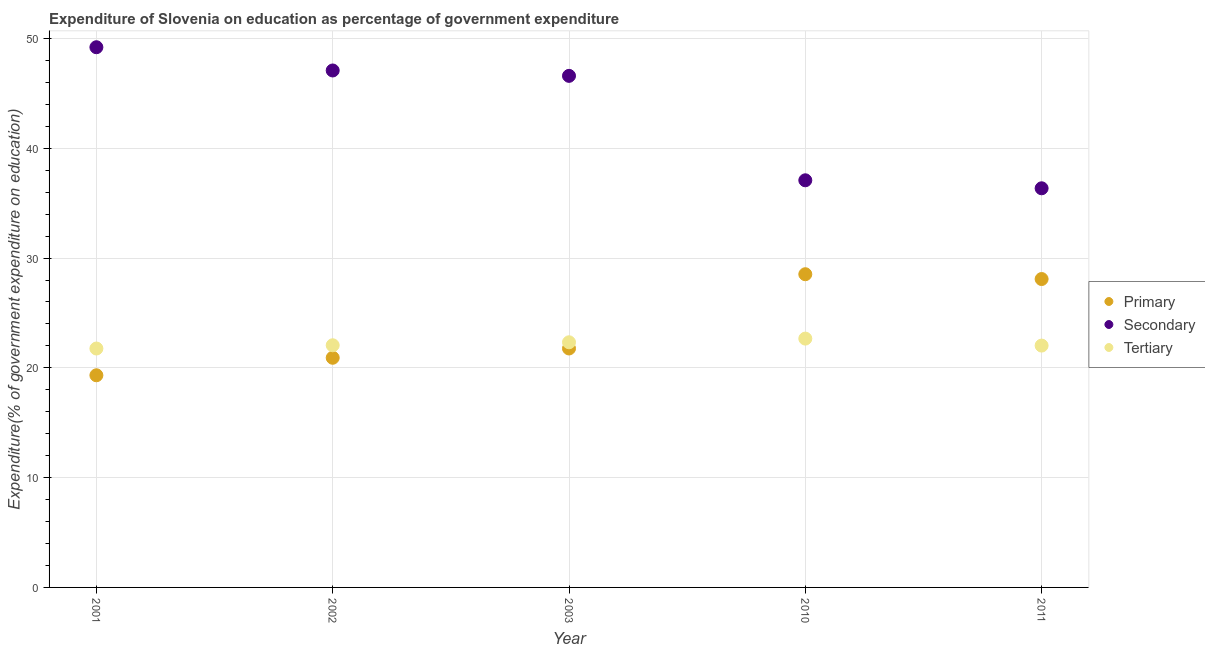How many different coloured dotlines are there?
Give a very brief answer. 3. What is the expenditure on tertiary education in 2003?
Make the answer very short. 22.33. Across all years, what is the maximum expenditure on secondary education?
Provide a short and direct response. 49.2. Across all years, what is the minimum expenditure on secondary education?
Offer a terse response. 36.35. In which year was the expenditure on secondary education minimum?
Offer a very short reply. 2011. What is the total expenditure on primary education in the graph?
Your response must be concise. 118.62. What is the difference between the expenditure on tertiary education in 2002 and that in 2011?
Offer a very short reply. 0.03. What is the difference between the expenditure on primary education in 2003 and the expenditure on tertiary education in 2001?
Make the answer very short. 0. What is the average expenditure on primary education per year?
Your response must be concise. 23.72. In the year 2011, what is the difference between the expenditure on tertiary education and expenditure on secondary education?
Offer a terse response. -14.33. In how many years, is the expenditure on secondary education greater than 22 %?
Offer a very short reply. 5. What is the ratio of the expenditure on secondary education in 2001 to that in 2002?
Give a very brief answer. 1.04. Is the expenditure on tertiary education in 2002 less than that in 2011?
Offer a terse response. No. What is the difference between the highest and the second highest expenditure on secondary education?
Give a very brief answer. 2.12. What is the difference between the highest and the lowest expenditure on tertiary education?
Your response must be concise. 0.9. Is the sum of the expenditure on primary education in 2001 and 2011 greater than the maximum expenditure on secondary education across all years?
Your answer should be very brief. No. Is it the case that in every year, the sum of the expenditure on primary education and expenditure on secondary education is greater than the expenditure on tertiary education?
Make the answer very short. Yes. Does the expenditure on tertiary education monotonically increase over the years?
Offer a terse response. No. How many dotlines are there?
Keep it short and to the point. 3. Are the values on the major ticks of Y-axis written in scientific E-notation?
Your answer should be very brief. No. Where does the legend appear in the graph?
Offer a very short reply. Center right. How many legend labels are there?
Offer a very short reply. 3. How are the legend labels stacked?
Offer a very short reply. Vertical. What is the title of the graph?
Keep it short and to the point. Expenditure of Slovenia on education as percentage of government expenditure. Does "Infant(male)" appear as one of the legend labels in the graph?
Offer a terse response. No. What is the label or title of the Y-axis?
Provide a short and direct response. Expenditure(% of government expenditure on education). What is the Expenditure(% of government expenditure on education) of Primary in 2001?
Offer a terse response. 19.32. What is the Expenditure(% of government expenditure on education) of Secondary in 2001?
Give a very brief answer. 49.2. What is the Expenditure(% of government expenditure on education) in Tertiary in 2001?
Keep it short and to the point. 21.76. What is the Expenditure(% of government expenditure on education) of Primary in 2002?
Ensure brevity in your answer.  20.92. What is the Expenditure(% of government expenditure on education) in Secondary in 2002?
Your response must be concise. 47.08. What is the Expenditure(% of government expenditure on education) of Tertiary in 2002?
Keep it short and to the point. 22.06. What is the Expenditure(% of government expenditure on education) in Primary in 2003?
Offer a terse response. 21.76. What is the Expenditure(% of government expenditure on education) of Secondary in 2003?
Provide a succinct answer. 46.59. What is the Expenditure(% of government expenditure on education) of Tertiary in 2003?
Your answer should be compact. 22.33. What is the Expenditure(% of government expenditure on education) in Primary in 2010?
Give a very brief answer. 28.53. What is the Expenditure(% of government expenditure on education) in Secondary in 2010?
Offer a terse response. 37.08. What is the Expenditure(% of government expenditure on education) of Tertiary in 2010?
Your response must be concise. 22.66. What is the Expenditure(% of government expenditure on education) in Primary in 2011?
Your answer should be very brief. 28.09. What is the Expenditure(% of government expenditure on education) in Secondary in 2011?
Provide a short and direct response. 36.35. What is the Expenditure(% of government expenditure on education) in Tertiary in 2011?
Provide a short and direct response. 22.03. Across all years, what is the maximum Expenditure(% of government expenditure on education) in Primary?
Keep it short and to the point. 28.53. Across all years, what is the maximum Expenditure(% of government expenditure on education) of Secondary?
Offer a terse response. 49.2. Across all years, what is the maximum Expenditure(% of government expenditure on education) of Tertiary?
Keep it short and to the point. 22.66. Across all years, what is the minimum Expenditure(% of government expenditure on education) in Primary?
Your answer should be very brief. 19.32. Across all years, what is the minimum Expenditure(% of government expenditure on education) in Secondary?
Your answer should be very brief. 36.35. Across all years, what is the minimum Expenditure(% of government expenditure on education) in Tertiary?
Ensure brevity in your answer.  21.76. What is the total Expenditure(% of government expenditure on education) of Primary in the graph?
Offer a very short reply. 118.62. What is the total Expenditure(% of government expenditure on education) of Secondary in the graph?
Your response must be concise. 216.32. What is the total Expenditure(% of government expenditure on education) of Tertiary in the graph?
Provide a succinct answer. 110.83. What is the difference between the Expenditure(% of government expenditure on education) of Primary in 2001 and that in 2002?
Your answer should be compact. -1.59. What is the difference between the Expenditure(% of government expenditure on education) of Secondary in 2001 and that in 2002?
Ensure brevity in your answer.  2.12. What is the difference between the Expenditure(% of government expenditure on education) of Tertiary in 2001 and that in 2002?
Your answer should be compact. -0.3. What is the difference between the Expenditure(% of government expenditure on education) in Primary in 2001 and that in 2003?
Your response must be concise. -2.44. What is the difference between the Expenditure(% of government expenditure on education) in Secondary in 2001 and that in 2003?
Your answer should be compact. 2.61. What is the difference between the Expenditure(% of government expenditure on education) of Tertiary in 2001 and that in 2003?
Provide a succinct answer. -0.57. What is the difference between the Expenditure(% of government expenditure on education) of Primary in 2001 and that in 2010?
Offer a very short reply. -9.2. What is the difference between the Expenditure(% of government expenditure on education) in Secondary in 2001 and that in 2010?
Make the answer very short. 12.12. What is the difference between the Expenditure(% of government expenditure on education) in Tertiary in 2001 and that in 2010?
Ensure brevity in your answer.  -0.9. What is the difference between the Expenditure(% of government expenditure on education) in Primary in 2001 and that in 2011?
Offer a terse response. -8.77. What is the difference between the Expenditure(% of government expenditure on education) in Secondary in 2001 and that in 2011?
Your answer should be compact. 12.85. What is the difference between the Expenditure(% of government expenditure on education) of Tertiary in 2001 and that in 2011?
Offer a terse response. -0.27. What is the difference between the Expenditure(% of government expenditure on education) in Primary in 2002 and that in 2003?
Your answer should be compact. -0.85. What is the difference between the Expenditure(% of government expenditure on education) in Secondary in 2002 and that in 2003?
Ensure brevity in your answer.  0.49. What is the difference between the Expenditure(% of government expenditure on education) of Tertiary in 2002 and that in 2003?
Provide a succinct answer. -0.27. What is the difference between the Expenditure(% of government expenditure on education) in Primary in 2002 and that in 2010?
Make the answer very short. -7.61. What is the difference between the Expenditure(% of government expenditure on education) in Secondary in 2002 and that in 2010?
Your answer should be compact. 10. What is the difference between the Expenditure(% of government expenditure on education) in Tertiary in 2002 and that in 2010?
Ensure brevity in your answer.  -0.61. What is the difference between the Expenditure(% of government expenditure on education) of Primary in 2002 and that in 2011?
Your answer should be compact. -7.17. What is the difference between the Expenditure(% of government expenditure on education) in Secondary in 2002 and that in 2011?
Your response must be concise. 10.73. What is the difference between the Expenditure(% of government expenditure on education) in Tertiary in 2002 and that in 2011?
Make the answer very short. 0.03. What is the difference between the Expenditure(% of government expenditure on education) of Primary in 2003 and that in 2010?
Your answer should be compact. -6.76. What is the difference between the Expenditure(% of government expenditure on education) of Secondary in 2003 and that in 2010?
Ensure brevity in your answer.  9.51. What is the difference between the Expenditure(% of government expenditure on education) of Tertiary in 2003 and that in 2010?
Make the answer very short. -0.34. What is the difference between the Expenditure(% of government expenditure on education) in Primary in 2003 and that in 2011?
Give a very brief answer. -6.33. What is the difference between the Expenditure(% of government expenditure on education) of Secondary in 2003 and that in 2011?
Provide a short and direct response. 10.24. What is the difference between the Expenditure(% of government expenditure on education) of Tertiary in 2003 and that in 2011?
Provide a succinct answer. 0.3. What is the difference between the Expenditure(% of government expenditure on education) in Primary in 2010 and that in 2011?
Provide a succinct answer. 0.44. What is the difference between the Expenditure(% of government expenditure on education) in Secondary in 2010 and that in 2011?
Provide a succinct answer. 0.73. What is the difference between the Expenditure(% of government expenditure on education) in Tertiary in 2010 and that in 2011?
Provide a short and direct response. 0.64. What is the difference between the Expenditure(% of government expenditure on education) in Primary in 2001 and the Expenditure(% of government expenditure on education) in Secondary in 2002?
Provide a short and direct response. -27.76. What is the difference between the Expenditure(% of government expenditure on education) of Primary in 2001 and the Expenditure(% of government expenditure on education) of Tertiary in 2002?
Your response must be concise. -2.73. What is the difference between the Expenditure(% of government expenditure on education) of Secondary in 2001 and the Expenditure(% of government expenditure on education) of Tertiary in 2002?
Ensure brevity in your answer.  27.15. What is the difference between the Expenditure(% of government expenditure on education) of Primary in 2001 and the Expenditure(% of government expenditure on education) of Secondary in 2003?
Make the answer very short. -27.27. What is the difference between the Expenditure(% of government expenditure on education) in Primary in 2001 and the Expenditure(% of government expenditure on education) in Tertiary in 2003?
Your response must be concise. -3. What is the difference between the Expenditure(% of government expenditure on education) in Secondary in 2001 and the Expenditure(% of government expenditure on education) in Tertiary in 2003?
Ensure brevity in your answer.  26.87. What is the difference between the Expenditure(% of government expenditure on education) of Primary in 2001 and the Expenditure(% of government expenditure on education) of Secondary in 2010?
Offer a terse response. -17.76. What is the difference between the Expenditure(% of government expenditure on education) in Primary in 2001 and the Expenditure(% of government expenditure on education) in Tertiary in 2010?
Ensure brevity in your answer.  -3.34. What is the difference between the Expenditure(% of government expenditure on education) in Secondary in 2001 and the Expenditure(% of government expenditure on education) in Tertiary in 2010?
Make the answer very short. 26.54. What is the difference between the Expenditure(% of government expenditure on education) in Primary in 2001 and the Expenditure(% of government expenditure on education) in Secondary in 2011?
Your answer should be compact. -17.03. What is the difference between the Expenditure(% of government expenditure on education) in Primary in 2001 and the Expenditure(% of government expenditure on education) in Tertiary in 2011?
Ensure brevity in your answer.  -2.7. What is the difference between the Expenditure(% of government expenditure on education) in Secondary in 2001 and the Expenditure(% of government expenditure on education) in Tertiary in 2011?
Make the answer very short. 27.18. What is the difference between the Expenditure(% of government expenditure on education) in Primary in 2002 and the Expenditure(% of government expenditure on education) in Secondary in 2003?
Your answer should be compact. -25.68. What is the difference between the Expenditure(% of government expenditure on education) of Primary in 2002 and the Expenditure(% of government expenditure on education) of Tertiary in 2003?
Your answer should be compact. -1.41. What is the difference between the Expenditure(% of government expenditure on education) in Secondary in 2002 and the Expenditure(% of government expenditure on education) in Tertiary in 2003?
Your response must be concise. 24.76. What is the difference between the Expenditure(% of government expenditure on education) in Primary in 2002 and the Expenditure(% of government expenditure on education) in Secondary in 2010?
Ensure brevity in your answer.  -16.16. What is the difference between the Expenditure(% of government expenditure on education) of Primary in 2002 and the Expenditure(% of government expenditure on education) of Tertiary in 2010?
Offer a very short reply. -1.75. What is the difference between the Expenditure(% of government expenditure on education) in Secondary in 2002 and the Expenditure(% of government expenditure on education) in Tertiary in 2010?
Provide a succinct answer. 24.42. What is the difference between the Expenditure(% of government expenditure on education) in Primary in 2002 and the Expenditure(% of government expenditure on education) in Secondary in 2011?
Offer a very short reply. -15.44. What is the difference between the Expenditure(% of government expenditure on education) of Primary in 2002 and the Expenditure(% of government expenditure on education) of Tertiary in 2011?
Provide a short and direct response. -1.11. What is the difference between the Expenditure(% of government expenditure on education) in Secondary in 2002 and the Expenditure(% of government expenditure on education) in Tertiary in 2011?
Your answer should be very brief. 25.06. What is the difference between the Expenditure(% of government expenditure on education) in Primary in 2003 and the Expenditure(% of government expenditure on education) in Secondary in 2010?
Make the answer very short. -15.32. What is the difference between the Expenditure(% of government expenditure on education) in Primary in 2003 and the Expenditure(% of government expenditure on education) in Tertiary in 2010?
Make the answer very short. -0.9. What is the difference between the Expenditure(% of government expenditure on education) in Secondary in 2003 and the Expenditure(% of government expenditure on education) in Tertiary in 2010?
Your answer should be very brief. 23.93. What is the difference between the Expenditure(% of government expenditure on education) of Primary in 2003 and the Expenditure(% of government expenditure on education) of Secondary in 2011?
Provide a short and direct response. -14.59. What is the difference between the Expenditure(% of government expenditure on education) of Primary in 2003 and the Expenditure(% of government expenditure on education) of Tertiary in 2011?
Your answer should be very brief. -0.26. What is the difference between the Expenditure(% of government expenditure on education) in Secondary in 2003 and the Expenditure(% of government expenditure on education) in Tertiary in 2011?
Your response must be concise. 24.57. What is the difference between the Expenditure(% of government expenditure on education) in Primary in 2010 and the Expenditure(% of government expenditure on education) in Secondary in 2011?
Provide a succinct answer. -7.83. What is the difference between the Expenditure(% of government expenditure on education) in Primary in 2010 and the Expenditure(% of government expenditure on education) in Tertiary in 2011?
Make the answer very short. 6.5. What is the difference between the Expenditure(% of government expenditure on education) of Secondary in 2010 and the Expenditure(% of government expenditure on education) of Tertiary in 2011?
Keep it short and to the point. 15.06. What is the average Expenditure(% of government expenditure on education) in Primary per year?
Provide a short and direct response. 23.72. What is the average Expenditure(% of government expenditure on education) of Secondary per year?
Offer a very short reply. 43.26. What is the average Expenditure(% of government expenditure on education) of Tertiary per year?
Make the answer very short. 22.17. In the year 2001, what is the difference between the Expenditure(% of government expenditure on education) of Primary and Expenditure(% of government expenditure on education) of Secondary?
Ensure brevity in your answer.  -29.88. In the year 2001, what is the difference between the Expenditure(% of government expenditure on education) in Primary and Expenditure(% of government expenditure on education) in Tertiary?
Offer a terse response. -2.44. In the year 2001, what is the difference between the Expenditure(% of government expenditure on education) in Secondary and Expenditure(% of government expenditure on education) in Tertiary?
Provide a succinct answer. 27.44. In the year 2002, what is the difference between the Expenditure(% of government expenditure on education) of Primary and Expenditure(% of government expenditure on education) of Secondary?
Your answer should be compact. -26.17. In the year 2002, what is the difference between the Expenditure(% of government expenditure on education) of Primary and Expenditure(% of government expenditure on education) of Tertiary?
Provide a short and direct response. -1.14. In the year 2002, what is the difference between the Expenditure(% of government expenditure on education) of Secondary and Expenditure(% of government expenditure on education) of Tertiary?
Your response must be concise. 25.03. In the year 2003, what is the difference between the Expenditure(% of government expenditure on education) of Primary and Expenditure(% of government expenditure on education) of Secondary?
Your answer should be compact. -24.83. In the year 2003, what is the difference between the Expenditure(% of government expenditure on education) in Primary and Expenditure(% of government expenditure on education) in Tertiary?
Offer a terse response. -0.56. In the year 2003, what is the difference between the Expenditure(% of government expenditure on education) of Secondary and Expenditure(% of government expenditure on education) of Tertiary?
Keep it short and to the point. 24.27. In the year 2010, what is the difference between the Expenditure(% of government expenditure on education) in Primary and Expenditure(% of government expenditure on education) in Secondary?
Keep it short and to the point. -8.56. In the year 2010, what is the difference between the Expenditure(% of government expenditure on education) in Primary and Expenditure(% of government expenditure on education) in Tertiary?
Provide a succinct answer. 5.86. In the year 2010, what is the difference between the Expenditure(% of government expenditure on education) in Secondary and Expenditure(% of government expenditure on education) in Tertiary?
Give a very brief answer. 14.42. In the year 2011, what is the difference between the Expenditure(% of government expenditure on education) in Primary and Expenditure(% of government expenditure on education) in Secondary?
Your answer should be very brief. -8.26. In the year 2011, what is the difference between the Expenditure(% of government expenditure on education) in Primary and Expenditure(% of government expenditure on education) in Tertiary?
Give a very brief answer. 6.06. In the year 2011, what is the difference between the Expenditure(% of government expenditure on education) in Secondary and Expenditure(% of government expenditure on education) in Tertiary?
Your answer should be compact. 14.33. What is the ratio of the Expenditure(% of government expenditure on education) of Primary in 2001 to that in 2002?
Your answer should be very brief. 0.92. What is the ratio of the Expenditure(% of government expenditure on education) in Secondary in 2001 to that in 2002?
Provide a succinct answer. 1.04. What is the ratio of the Expenditure(% of government expenditure on education) in Tertiary in 2001 to that in 2002?
Provide a short and direct response. 0.99. What is the ratio of the Expenditure(% of government expenditure on education) in Primary in 2001 to that in 2003?
Your answer should be very brief. 0.89. What is the ratio of the Expenditure(% of government expenditure on education) in Secondary in 2001 to that in 2003?
Give a very brief answer. 1.06. What is the ratio of the Expenditure(% of government expenditure on education) of Tertiary in 2001 to that in 2003?
Your answer should be very brief. 0.97. What is the ratio of the Expenditure(% of government expenditure on education) in Primary in 2001 to that in 2010?
Provide a succinct answer. 0.68. What is the ratio of the Expenditure(% of government expenditure on education) of Secondary in 2001 to that in 2010?
Make the answer very short. 1.33. What is the ratio of the Expenditure(% of government expenditure on education) of Tertiary in 2001 to that in 2010?
Offer a terse response. 0.96. What is the ratio of the Expenditure(% of government expenditure on education) of Primary in 2001 to that in 2011?
Your response must be concise. 0.69. What is the ratio of the Expenditure(% of government expenditure on education) of Secondary in 2001 to that in 2011?
Provide a short and direct response. 1.35. What is the ratio of the Expenditure(% of government expenditure on education) in Tertiary in 2001 to that in 2011?
Offer a terse response. 0.99. What is the ratio of the Expenditure(% of government expenditure on education) in Primary in 2002 to that in 2003?
Provide a short and direct response. 0.96. What is the ratio of the Expenditure(% of government expenditure on education) in Secondary in 2002 to that in 2003?
Provide a short and direct response. 1.01. What is the ratio of the Expenditure(% of government expenditure on education) of Tertiary in 2002 to that in 2003?
Offer a terse response. 0.99. What is the ratio of the Expenditure(% of government expenditure on education) of Primary in 2002 to that in 2010?
Give a very brief answer. 0.73. What is the ratio of the Expenditure(% of government expenditure on education) in Secondary in 2002 to that in 2010?
Your answer should be compact. 1.27. What is the ratio of the Expenditure(% of government expenditure on education) of Tertiary in 2002 to that in 2010?
Your answer should be compact. 0.97. What is the ratio of the Expenditure(% of government expenditure on education) of Primary in 2002 to that in 2011?
Offer a very short reply. 0.74. What is the ratio of the Expenditure(% of government expenditure on education) of Secondary in 2002 to that in 2011?
Ensure brevity in your answer.  1.3. What is the ratio of the Expenditure(% of government expenditure on education) of Tertiary in 2002 to that in 2011?
Offer a very short reply. 1. What is the ratio of the Expenditure(% of government expenditure on education) in Primary in 2003 to that in 2010?
Keep it short and to the point. 0.76. What is the ratio of the Expenditure(% of government expenditure on education) of Secondary in 2003 to that in 2010?
Offer a very short reply. 1.26. What is the ratio of the Expenditure(% of government expenditure on education) in Tertiary in 2003 to that in 2010?
Provide a succinct answer. 0.99. What is the ratio of the Expenditure(% of government expenditure on education) in Primary in 2003 to that in 2011?
Provide a short and direct response. 0.77. What is the ratio of the Expenditure(% of government expenditure on education) of Secondary in 2003 to that in 2011?
Provide a short and direct response. 1.28. What is the ratio of the Expenditure(% of government expenditure on education) in Tertiary in 2003 to that in 2011?
Give a very brief answer. 1.01. What is the ratio of the Expenditure(% of government expenditure on education) of Primary in 2010 to that in 2011?
Make the answer very short. 1.02. What is the ratio of the Expenditure(% of government expenditure on education) of Secondary in 2010 to that in 2011?
Ensure brevity in your answer.  1.02. What is the ratio of the Expenditure(% of government expenditure on education) in Tertiary in 2010 to that in 2011?
Give a very brief answer. 1.03. What is the difference between the highest and the second highest Expenditure(% of government expenditure on education) of Primary?
Make the answer very short. 0.44. What is the difference between the highest and the second highest Expenditure(% of government expenditure on education) in Secondary?
Your answer should be compact. 2.12. What is the difference between the highest and the second highest Expenditure(% of government expenditure on education) in Tertiary?
Your answer should be very brief. 0.34. What is the difference between the highest and the lowest Expenditure(% of government expenditure on education) of Primary?
Offer a very short reply. 9.2. What is the difference between the highest and the lowest Expenditure(% of government expenditure on education) of Secondary?
Keep it short and to the point. 12.85. What is the difference between the highest and the lowest Expenditure(% of government expenditure on education) in Tertiary?
Make the answer very short. 0.9. 